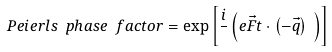<formula> <loc_0><loc_0><loc_500><loc_500>P e i e r l s \ p h a s e \ f a c t o r = \exp \left [ \frac { i } { } \left ( e \vec { F } t \cdot \left ( - \vec { q } \right ) \ \right ) \right ]</formula> 